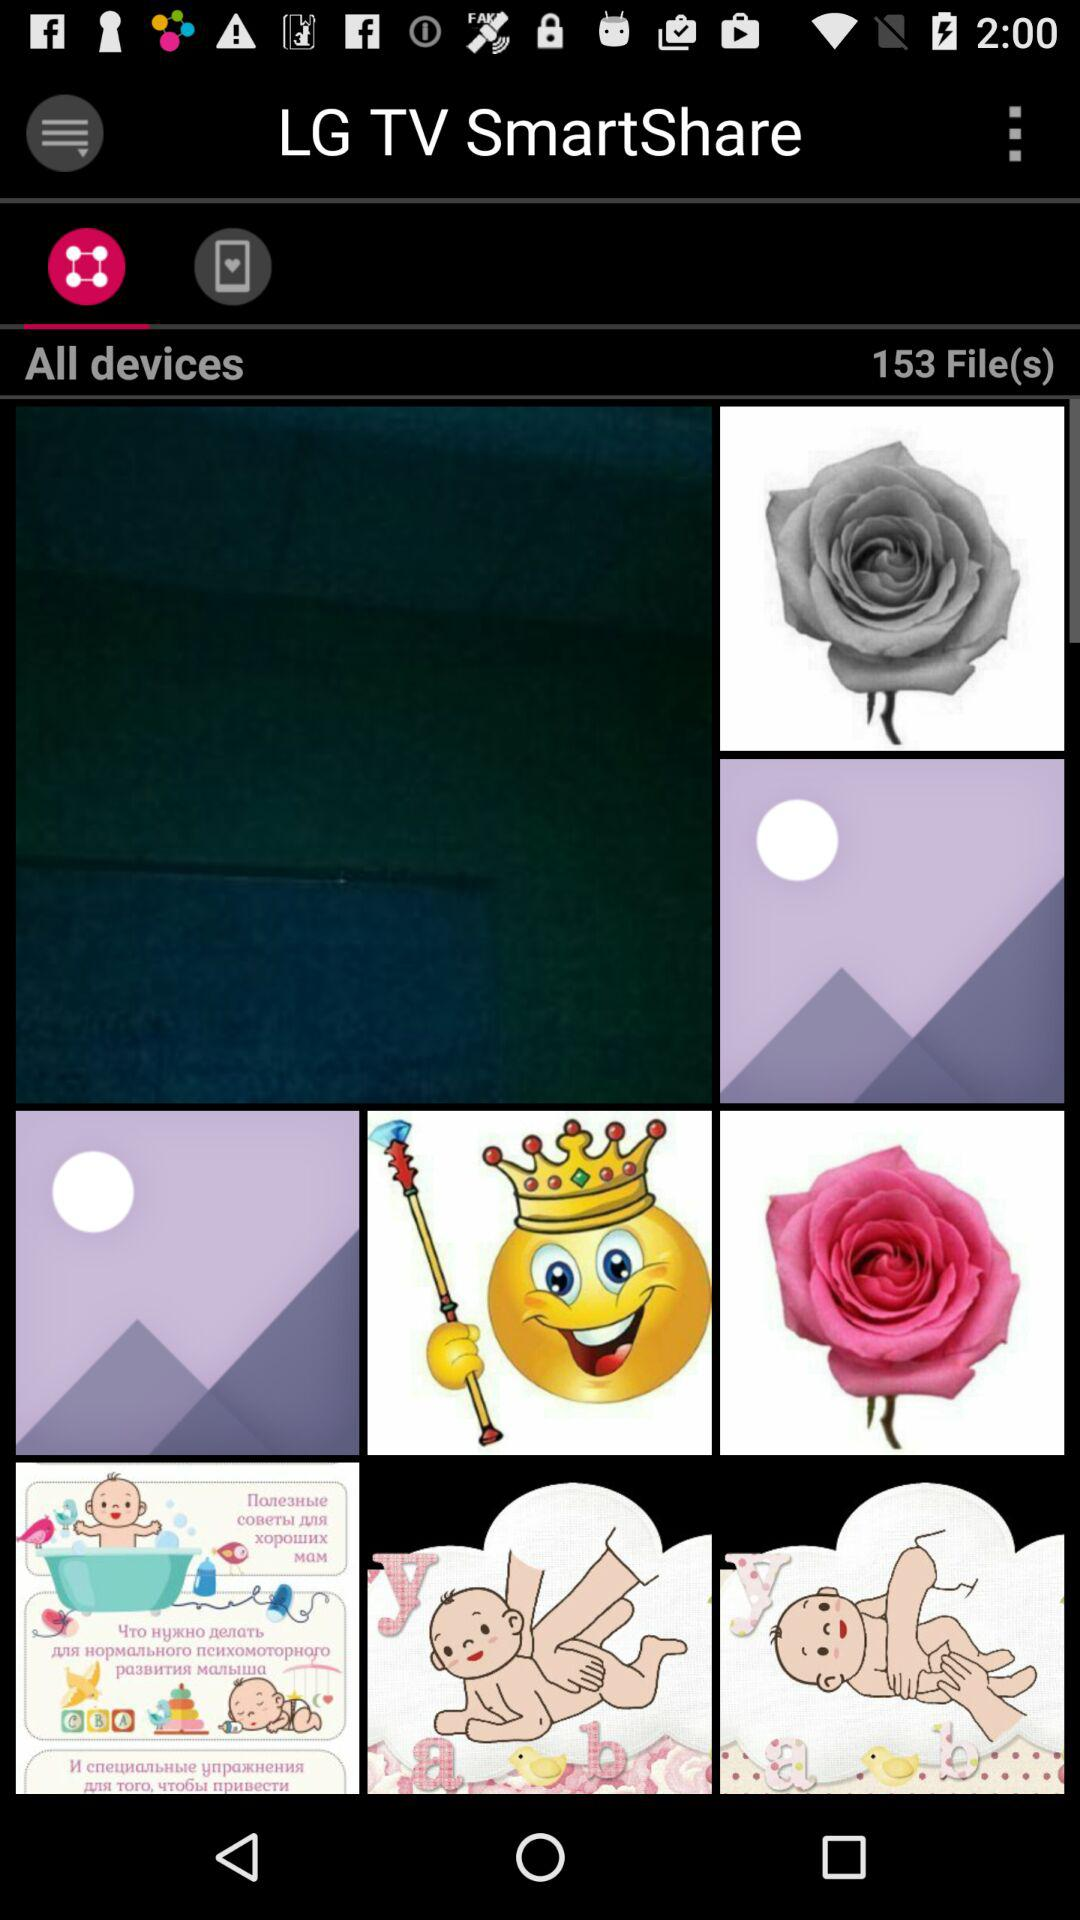How many followers are there?
When the provided information is insufficient, respond with <no answer>. <no answer> 